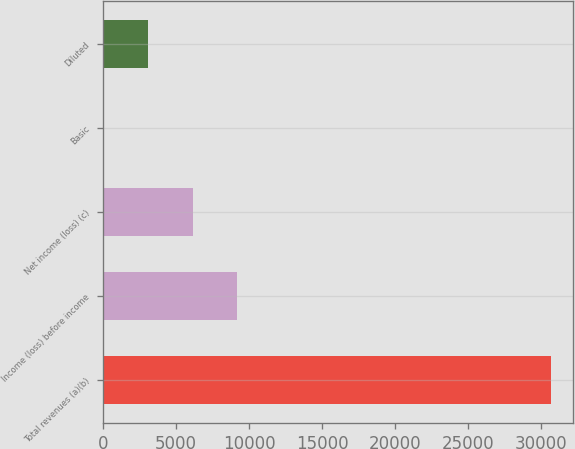<chart> <loc_0><loc_0><loc_500><loc_500><bar_chart><fcel>Total revenues (a)(b)<fcel>Income (loss) before income<fcel>Net income (loss) (c)<fcel>Basic<fcel>Diluted<nl><fcel>30645<fcel>9194.6<fcel>6130.26<fcel>1.58<fcel>3065.92<nl></chart> 